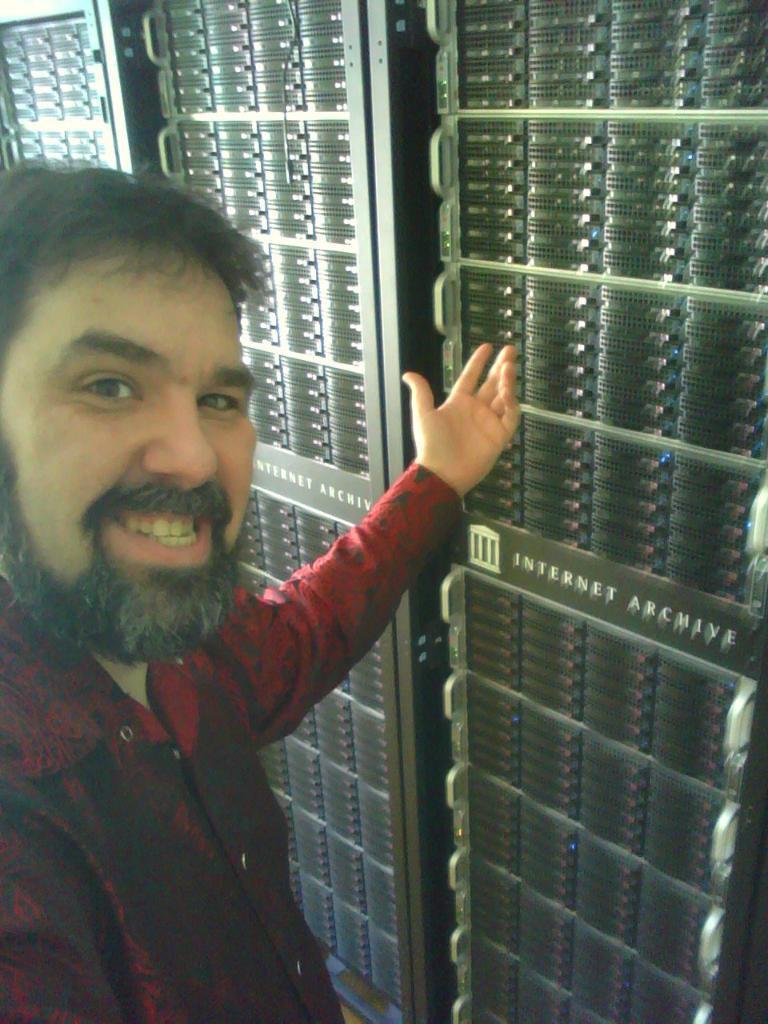In one or two sentences, can you explain what this image depicts? On the left side of the image we can see a person is smiling. In the background there are server racks. 